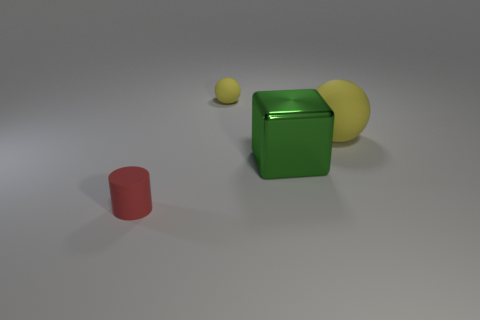Are there any other things that are made of the same material as the green cube?
Your answer should be compact. No. What is the material of the big sphere that is the same color as the small ball?
Your response must be concise. Rubber. What number of big rubber balls are the same color as the tiny ball?
Your answer should be very brief. 1. There is a matte ball in front of the small yellow matte sphere; is its color the same as the small thing right of the small red matte thing?
Your response must be concise. Yes. Are there any big metallic blocks in front of the red rubber object?
Ensure brevity in your answer.  No. What is the material of the tiny cylinder?
Ensure brevity in your answer.  Rubber. There is a tiny object that is right of the cylinder; what is its shape?
Give a very brief answer. Sphere. There is a thing that is the same color as the big matte ball; what is its size?
Your answer should be compact. Small. Is there a yellow matte cylinder that has the same size as the metal object?
Offer a terse response. No. Does the ball that is to the right of the big metal object have the same material as the small red object?
Give a very brief answer. Yes. 